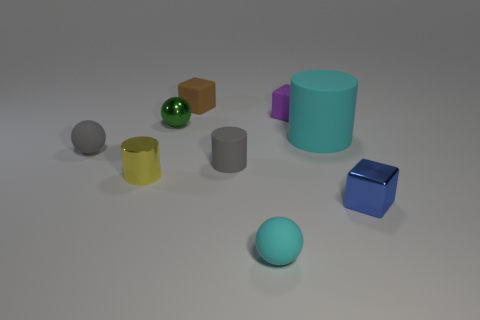Are any cyan things visible?
Provide a short and direct response. Yes. There is a cylinder that is the same material as the small green thing; what color is it?
Your answer should be compact. Yellow. What is the color of the tiny cylinder that is left of the tiny gray object to the right of the gray rubber thing that is left of the green thing?
Offer a terse response. Yellow. Does the green thing have the same size as the rubber cylinder that is right of the small cyan object?
Ensure brevity in your answer.  No. What number of things are objects that are on the left side of the blue metallic cube or cyan rubber objects that are on the right side of the purple rubber cube?
Your answer should be very brief. 8. The yellow thing that is the same size as the shiny block is what shape?
Your answer should be compact. Cylinder. The cyan rubber thing right of the tiny thing in front of the small cube in front of the green ball is what shape?
Offer a very short reply. Cylinder. Is the number of tiny brown rubber blocks that are on the right side of the blue thing the same as the number of big purple things?
Ensure brevity in your answer.  Yes. Do the yellow cylinder and the cyan cylinder have the same size?
Provide a short and direct response. No. How many matte things are cyan spheres or big yellow spheres?
Your response must be concise. 1. 